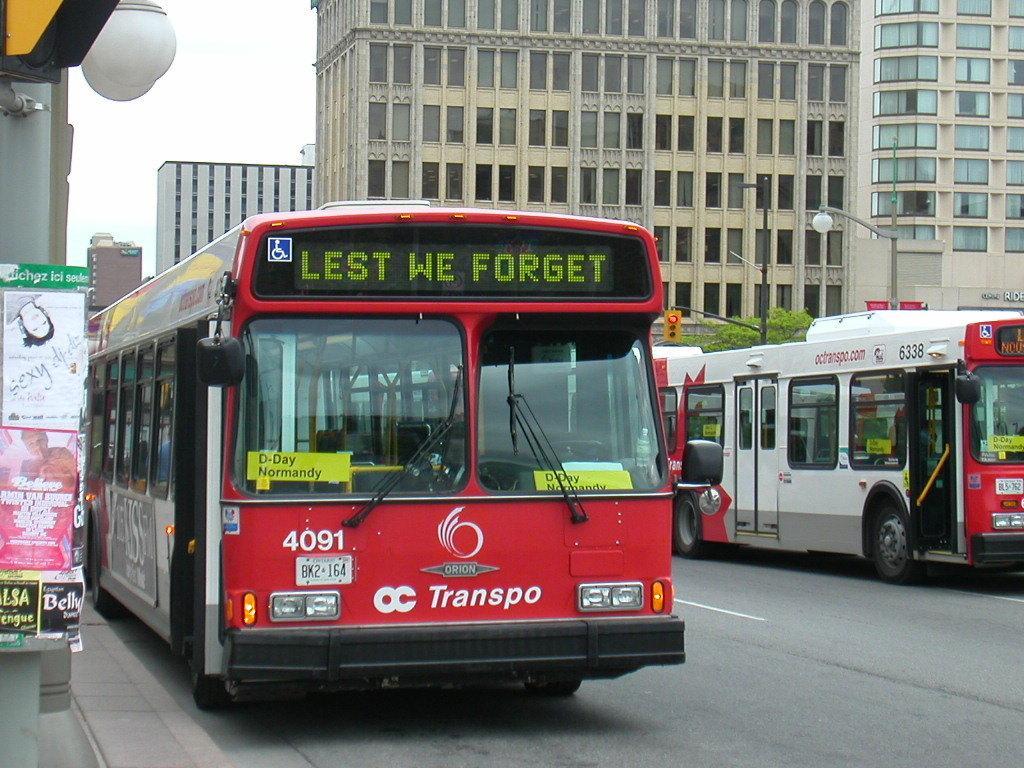In one or two sentences, can you explain what this image depicts? In this image there are buses on the road, beside them there are so many buildings and also there is a notice board. 